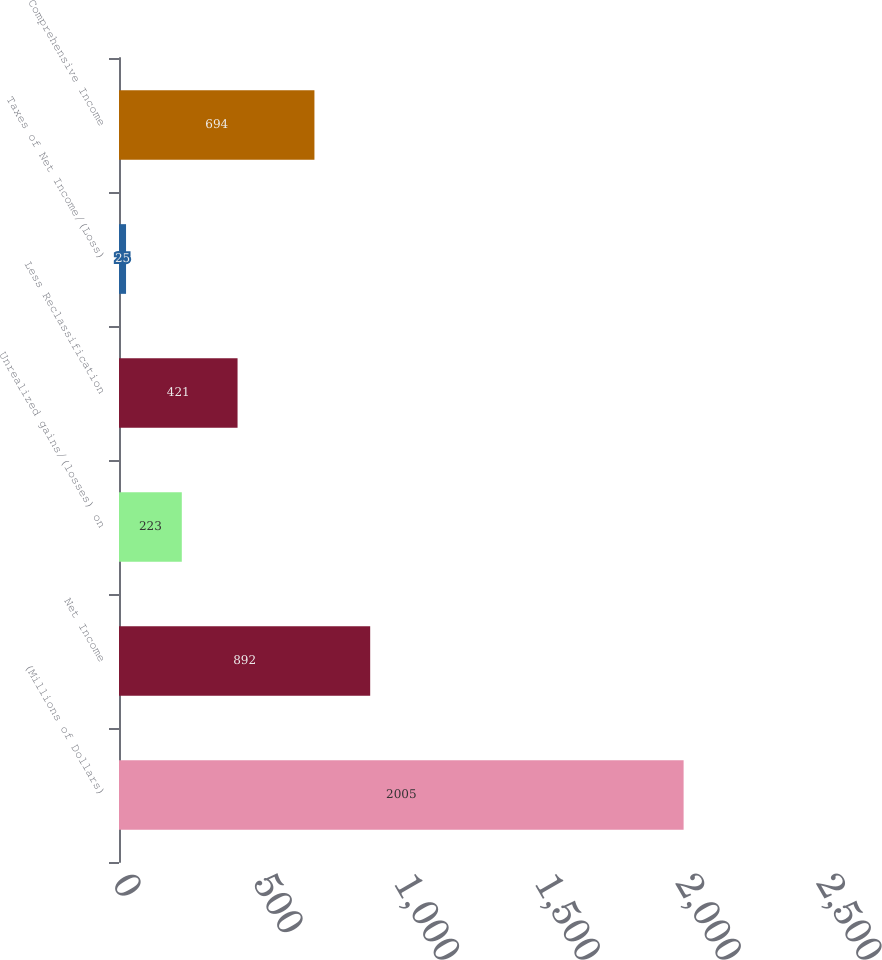Convert chart. <chart><loc_0><loc_0><loc_500><loc_500><bar_chart><fcel>(Millions of Dollars)<fcel>Net Income<fcel>Unrealized gains/(losses) on<fcel>Less Reclassification<fcel>Taxes of Net Income/(Loss)<fcel>Comprehensive Income<nl><fcel>2005<fcel>892<fcel>223<fcel>421<fcel>25<fcel>694<nl></chart> 